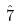Convert formula to latex. <formula><loc_0><loc_0><loc_500><loc_500>\hat { 7 }</formula> 